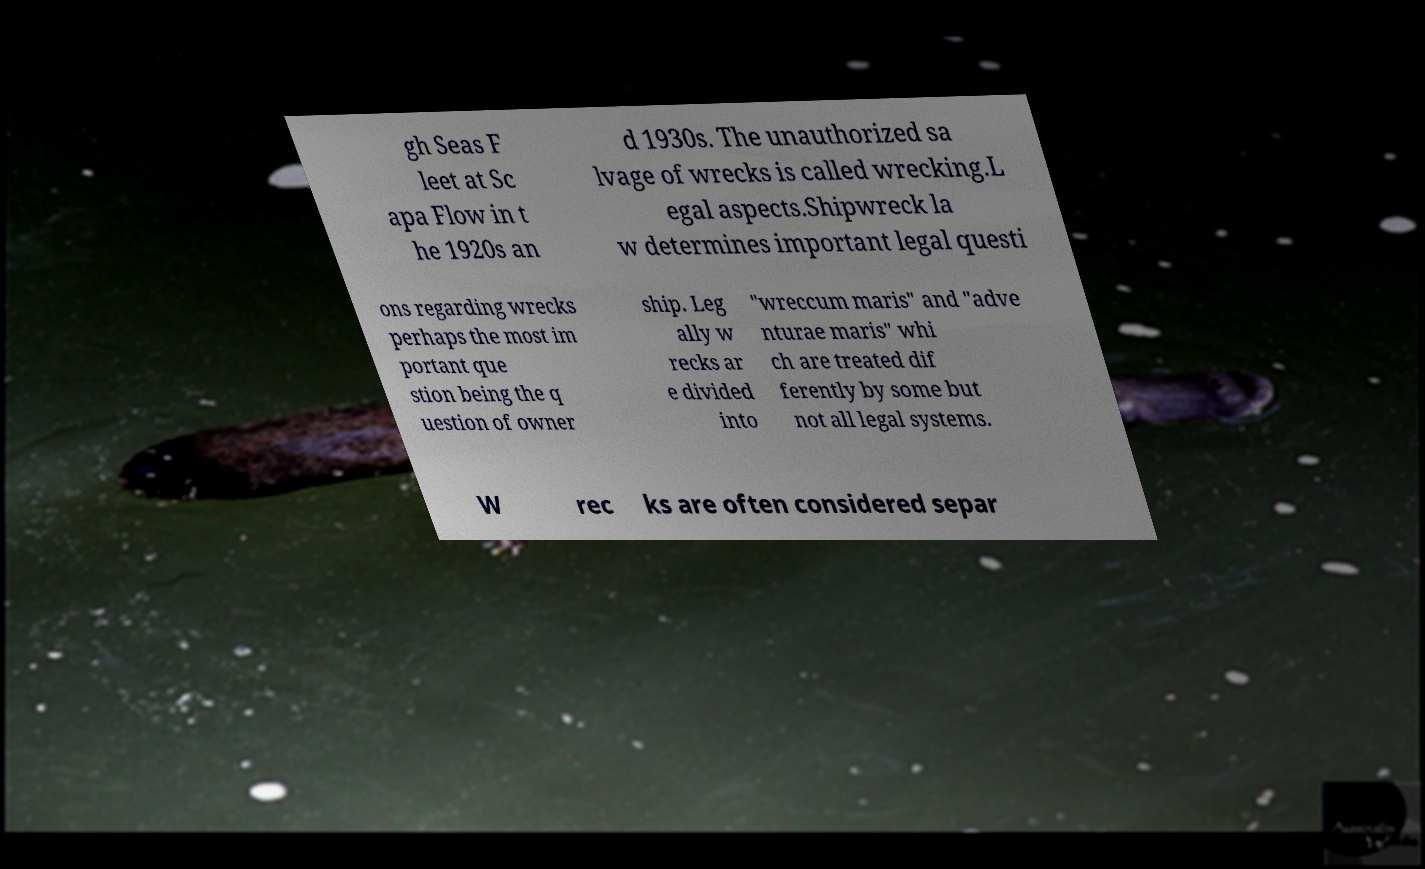Can you accurately transcribe the text from the provided image for me? gh Seas F leet at Sc apa Flow in t he 1920s an d 1930s. The unauthorized sa lvage of wrecks is called wrecking.L egal aspects.Shipwreck la w determines important legal questi ons regarding wrecks perhaps the most im portant que stion being the q uestion of owner ship. Leg ally w recks ar e divided into "wreccum maris" and "adve nturae maris" whi ch are treated dif ferently by some but not all legal systems. W rec ks are often considered separ 